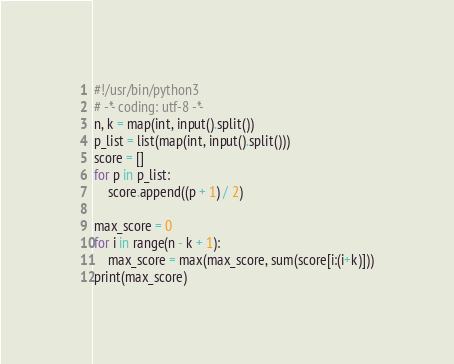Convert code to text. <code><loc_0><loc_0><loc_500><loc_500><_Python_>#!/usr/bin/python3
# -*- coding: utf-8 -*-
n, k = map(int, input().split())
p_list = list(map(int, input().split()))
score = []
for p in p_list:
    score.append((p + 1) / 2)

max_score = 0
for i in range(n - k + 1):
    max_score = max(max_score, sum(score[i:(i+k)]))
print(max_score)</code> 